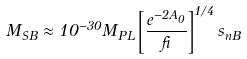<formula> <loc_0><loc_0><loc_500><loc_500>M _ { S B } \approx 1 0 ^ { - 3 0 } M _ { P L } \left [ \frac { e ^ { - 2 A _ { 0 } } } { \beta } \right ] ^ { 1 / 4 } s _ { n B }</formula> 